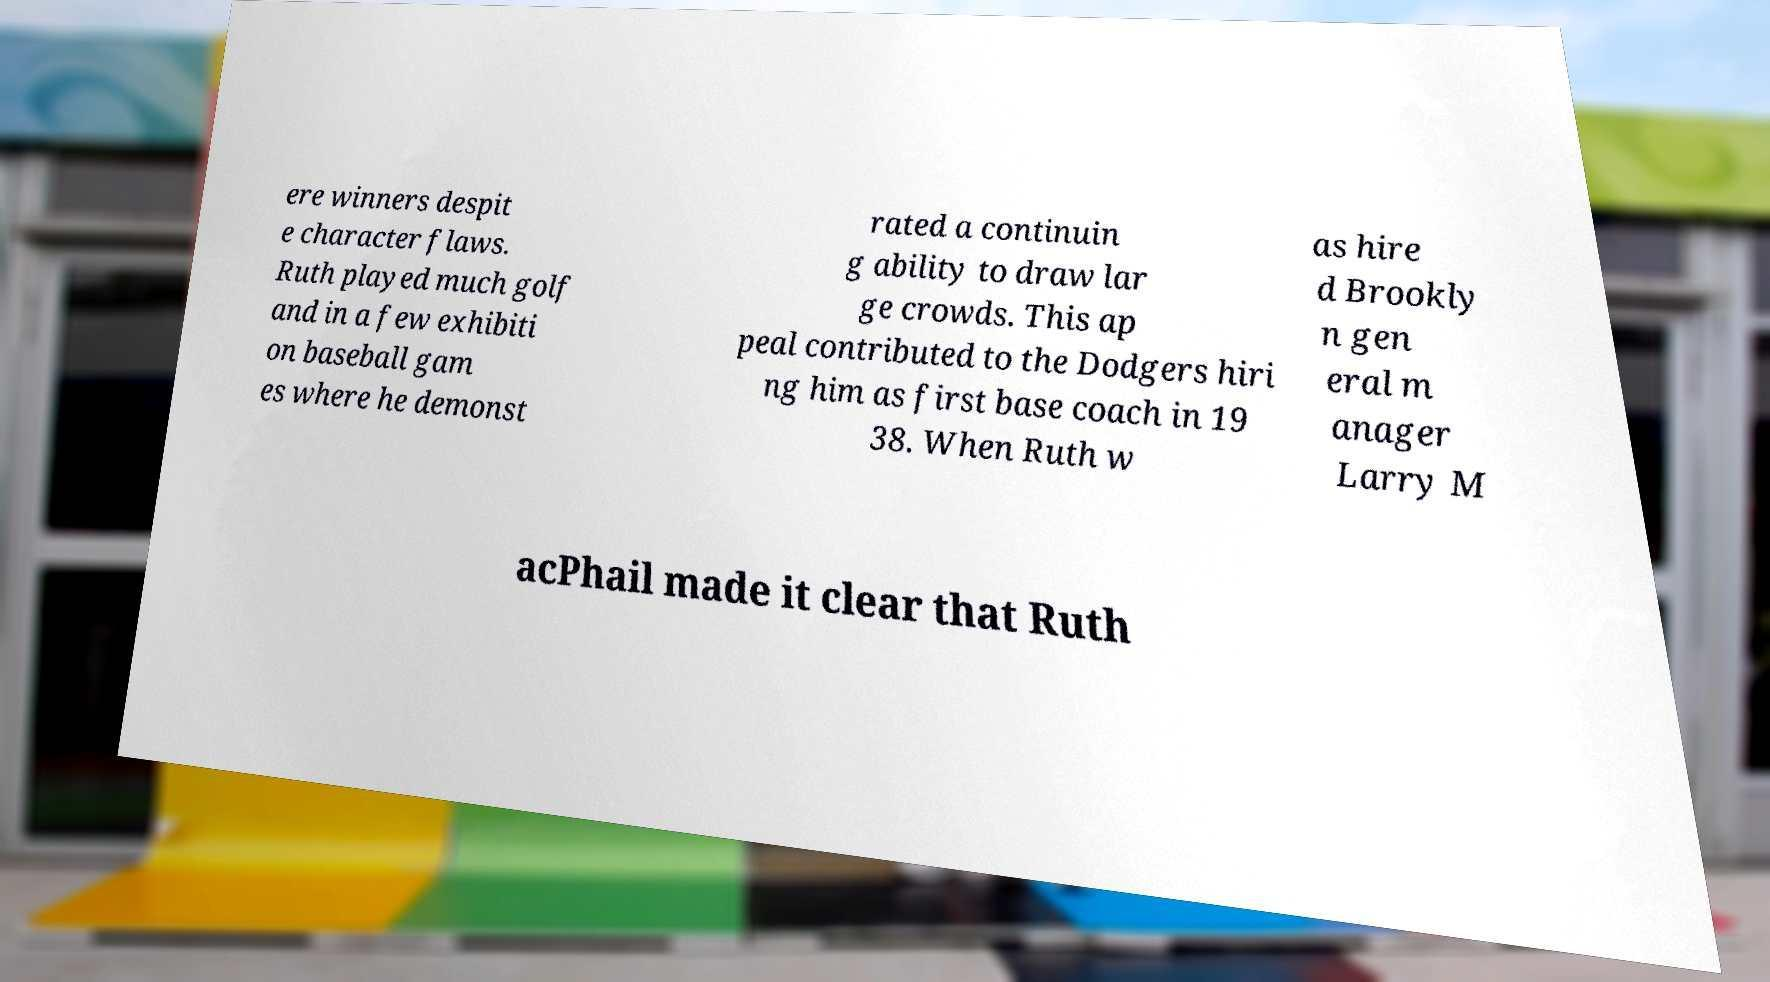For documentation purposes, I need the text within this image transcribed. Could you provide that? ere winners despit e character flaws. Ruth played much golf and in a few exhibiti on baseball gam es where he demonst rated a continuin g ability to draw lar ge crowds. This ap peal contributed to the Dodgers hiri ng him as first base coach in 19 38. When Ruth w as hire d Brookly n gen eral m anager Larry M acPhail made it clear that Ruth 